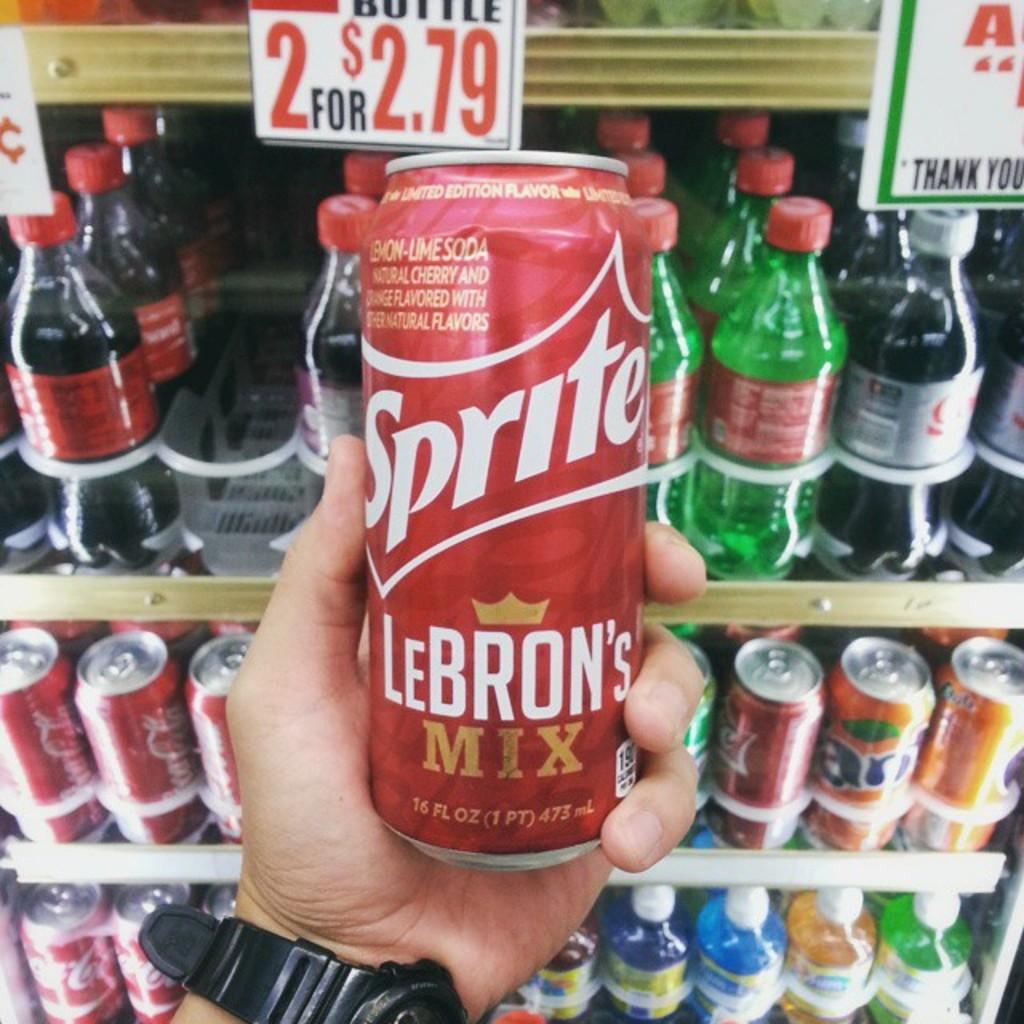What is the man in the image holding? The man is holding a tin. What can be seen on the man's wrist in the image? The man is wearing a watch. What is present in the background of the image? There are many bottles, tins, and a poster in the background of the image. What type of dress is the goldfish wearing in the image? There is no goldfish or dress present in the image. What is the man's selection of tins in the image? The provided facts do not mention the man's selection of tins; it only states that he is holding one tin. 